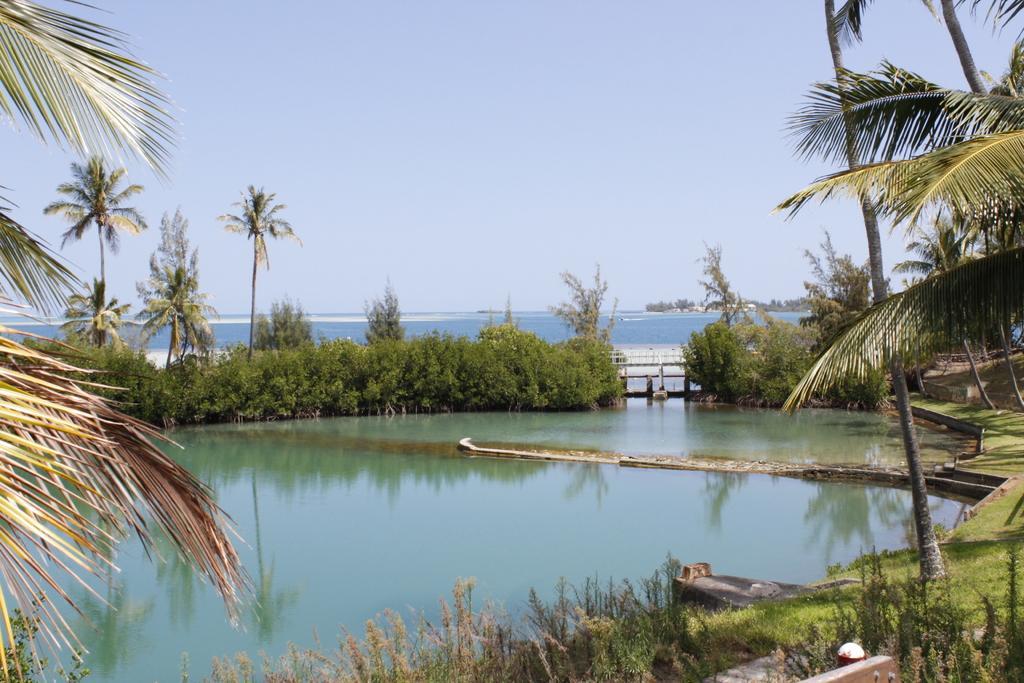How would you summarize this image in a sentence or two? There are plants at the bottom of this image. We can see the surface of water and trees in the middle of this image. The sky is in the background. 